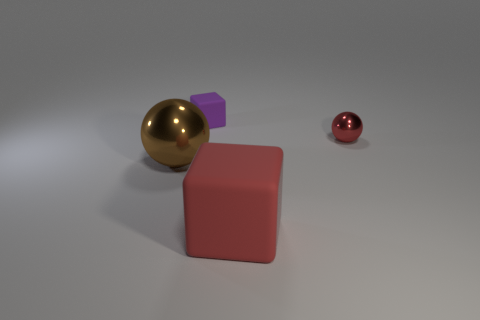Add 1 big red matte objects. How many objects exist? 5 Subtract 0 yellow spheres. How many objects are left? 4 Subtract all purple blocks. Subtract all small rubber cubes. How many objects are left? 2 Add 4 red rubber objects. How many red rubber objects are left? 5 Add 2 large red matte objects. How many large red matte objects exist? 3 